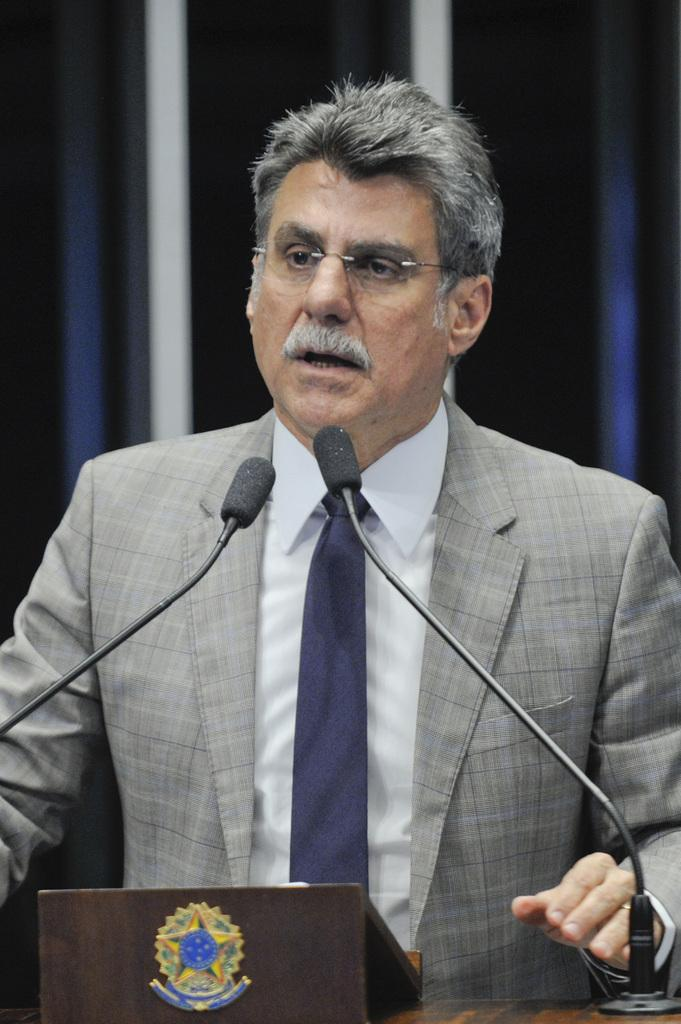What is the main subject of the image? There is a person in the image. What is the person wearing? The person is wearing a grey suit. What is the person doing in the image? The person is standing behind a podium. What can be seen on the podium? There are microphones on the podium. What type of caption is written on the person's shirt in the image? There is no caption written on the person's shirt in the image; they are wearing a grey suit. What fictional character is depicted on the podium in the image? There are no fictional characters depicted in the image; it features a person standing behind a podium with microphones. 